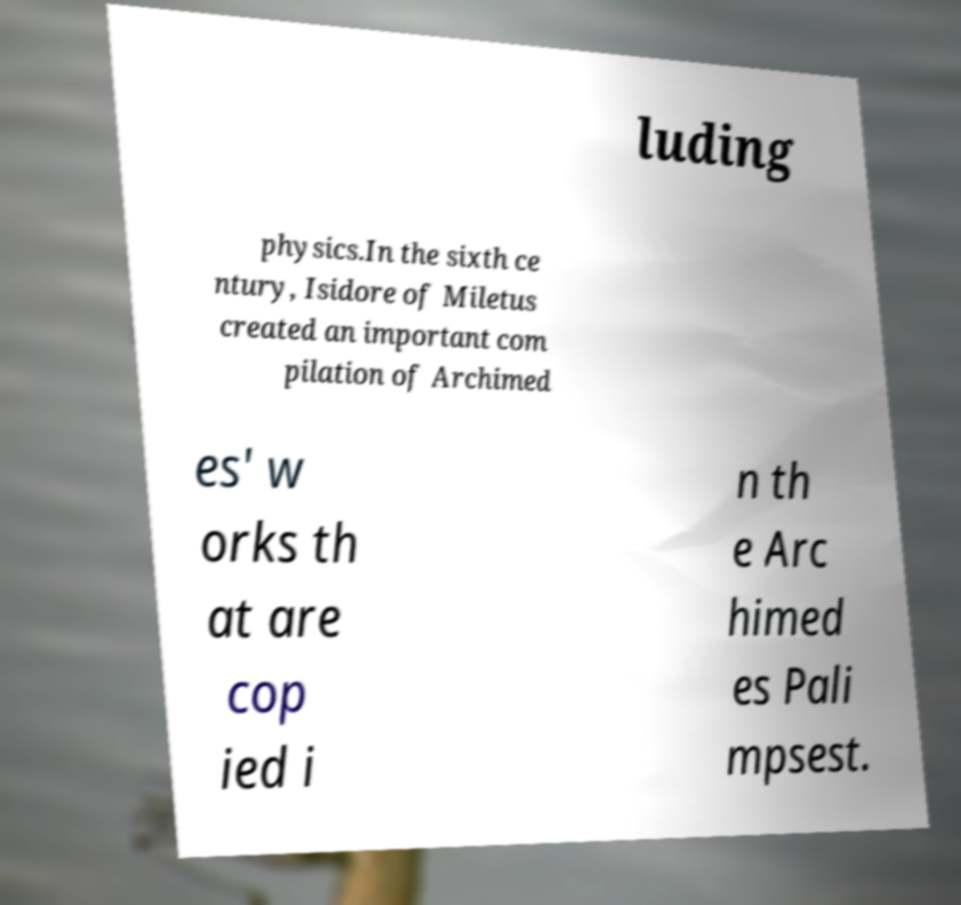Can you accurately transcribe the text from the provided image for me? luding physics.In the sixth ce ntury, Isidore of Miletus created an important com pilation of Archimed es' w orks th at are cop ied i n th e Arc himed es Pali mpsest. 